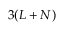Convert formula to latex. <formula><loc_0><loc_0><loc_500><loc_500>3 ( L + N )</formula> 